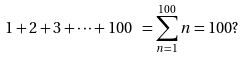Convert formula to latex. <formula><loc_0><loc_0><loc_500><loc_500>1 + 2 + 3 + \cdots + 1 0 0 \ = \sum _ { n = 1 } ^ { 1 0 0 } n = 1 0 0 ?</formula> 